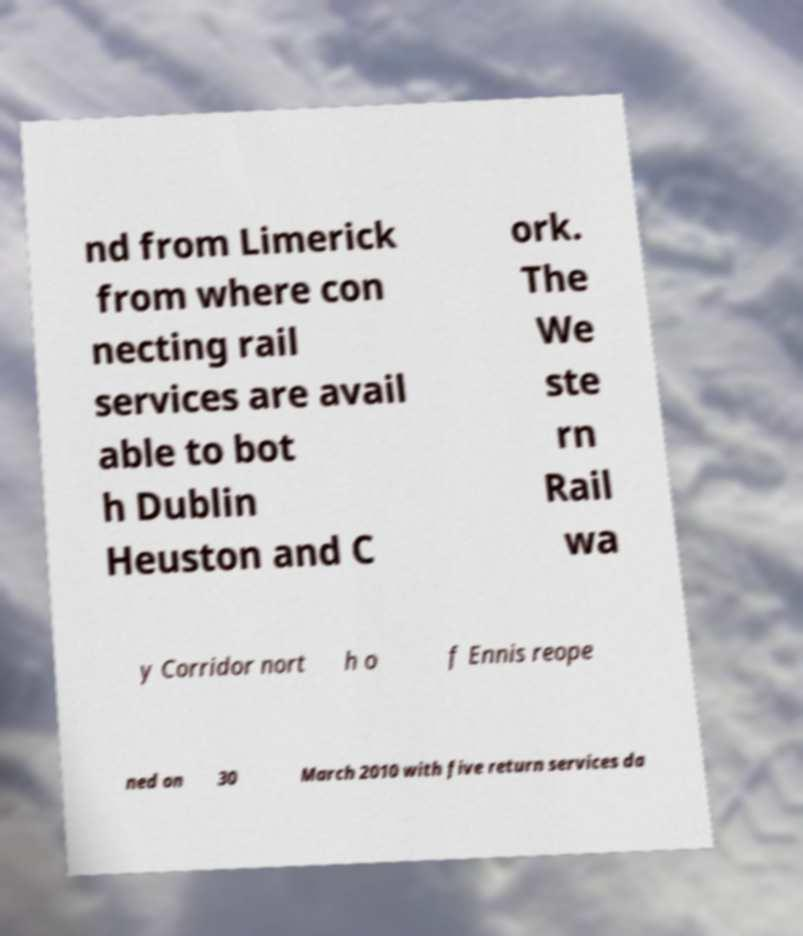Could you assist in decoding the text presented in this image and type it out clearly? nd from Limerick from where con necting rail services are avail able to bot h Dublin Heuston and C ork. The We ste rn Rail wa y Corridor nort h o f Ennis reope ned on 30 March 2010 with five return services da 